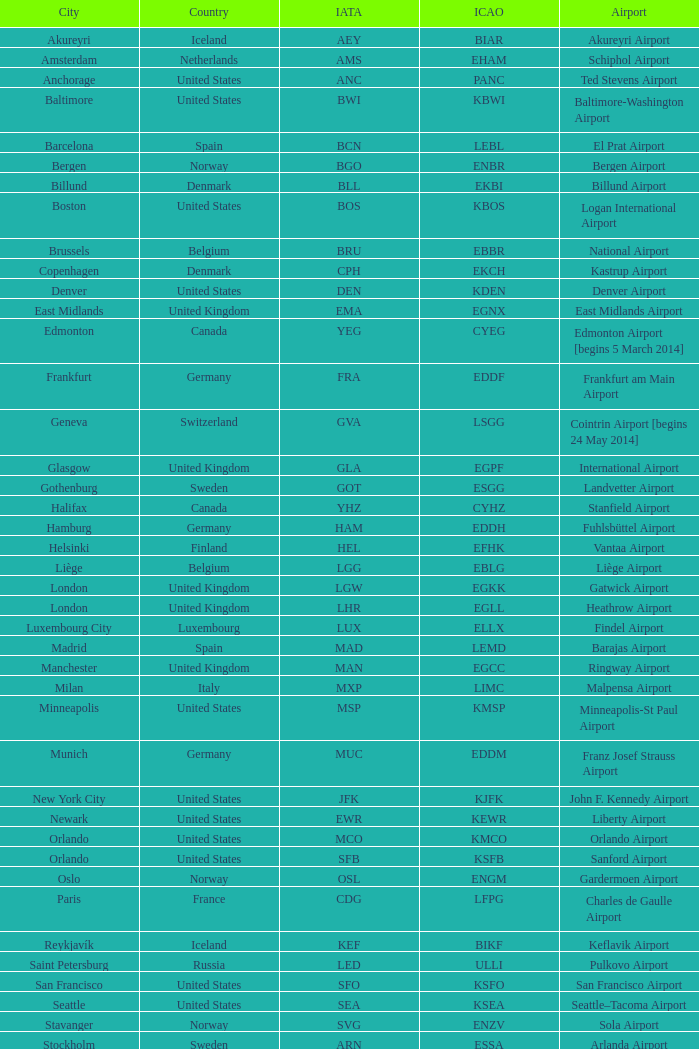What is the airport having the icao code ksea? Seattle–Tacoma Airport. 